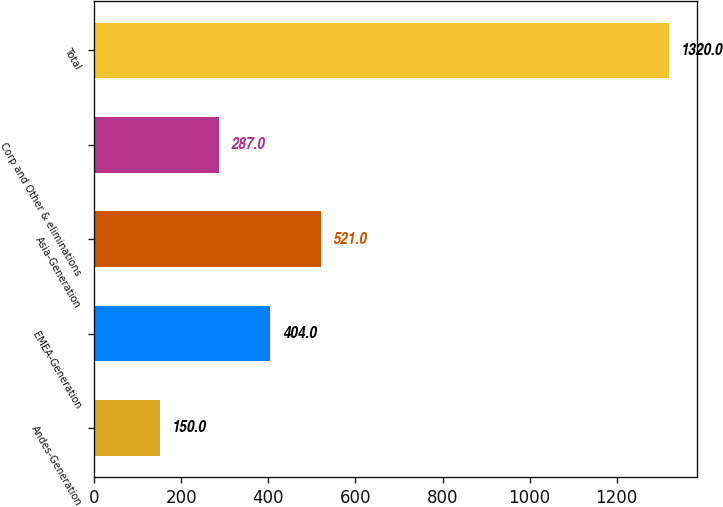Convert chart. <chart><loc_0><loc_0><loc_500><loc_500><bar_chart><fcel>Andes-Generation<fcel>EMEA-Generation<fcel>Asia-Generation<fcel>Corp and Other & eliminations<fcel>Total<nl><fcel>150<fcel>404<fcel>521<fcel>287<fcel>1320<nl></chart> 